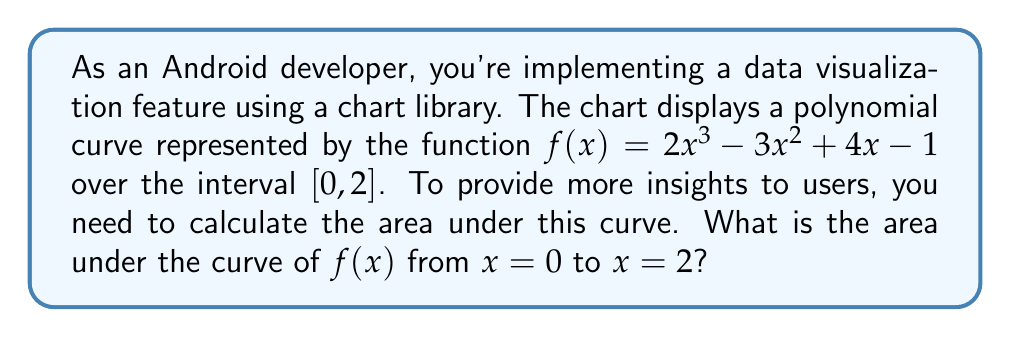Can you answer this question? To find the area under the curve, we need to calculate the definite integral of $f(x)$ from 0 to 2. Let's break this down step-by-step:

1) The function is $f(x) = 2x^3 - 3x^2 + 4x - 1$

2) To find the area, we need to integrate $f(x)$ from 0 to 2:

   $$\int_0^2 (2x^3 - 3x^2 + 4x - 1) dx$$

3) Let's integrate each term:
   
   $$\int 2x^3 dx = \frac{1}{2}x^4$$
   $$\int -3x^2 dx = -x^3$$
   $$\int 4x dx = 2x^2$$
   $$\int -1 dx = -x$$

4) Now, our indefinite integral is:

   $$F(x) = \frac{1}{2}x^4 - x^3 + 2x^2 - x + C$$

5) To find the definite integral, we evaluate $F(2) - F(0)$:

   $$F(2) = \frac{1}{2}(2^4) - 2^3 + 2(2^2) - 2 = 8 - 8 + 8 - 2 = 6$$
   
   $$F(0) = \frac{1}{2}(0^4) - 0^3 + 2(0^2) - 0 = 0$$

6) Therefore, the area is:

   $$F(2) - F(0) = 6 - 0 = 6$$

Thus, the area under the curve from x = 0 to x = 2 is 6 square units.
Answer: 6 square units 